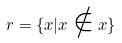Convert formula to latex. <formula><loc_0><loc_0><loc_500><loc_500>r = \{ x | x \notin x \}</formula> 